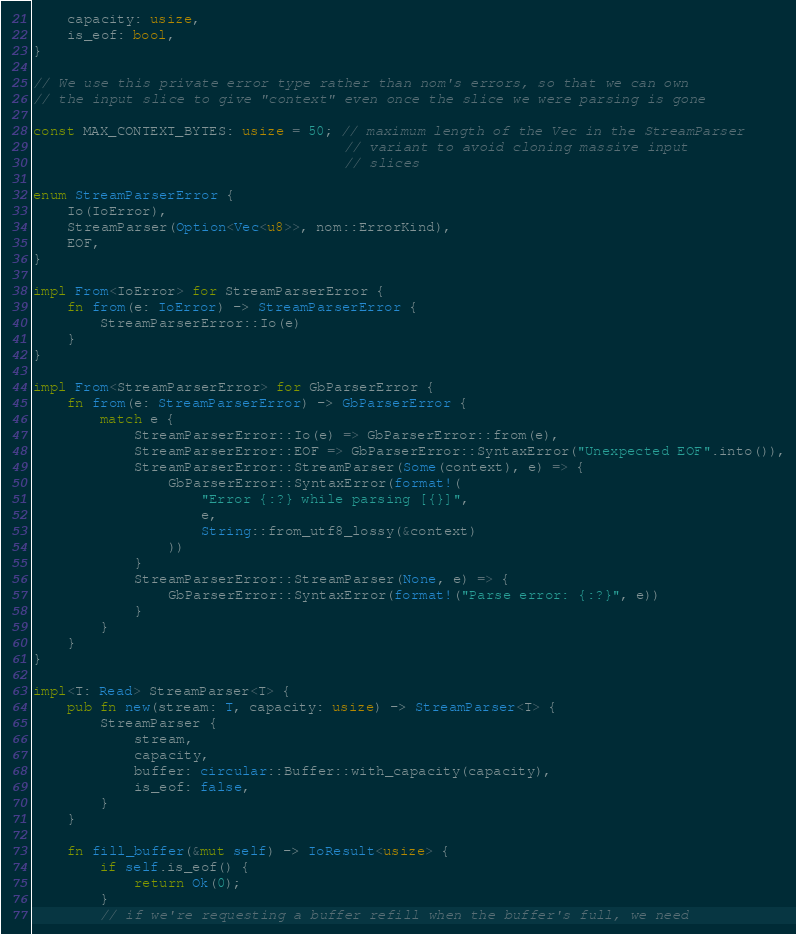<code> <loc_0><loc_0><loc_500><loc_500><_Rust_>    capacity: usize,
    is_eof: bool,
}

// We use this private error type rather than nom's errors, so that we can own
// the input slice to give "context" even once the slice we were parsing is gone

const MAX_CONTEXT_BYTES: usize = 50; // maximum length of the Vec in the StreamParser
                                     // variant to avoid cloning massive input
                                     // slices

enum StreamParserError {
    Io(IoError),
    StreamParser(Option<Vec<u8>>, nom::ErrorKind),
    EOF,
}

impl From<IoError> for StreamParserError {
    fn from(e: IoError) -> StreamParserError {
        StreamParserError::Io(e)
    }
}

impl From<StreamParserError> for GbParserError {
    fn from(e: StreamParserError) -> GbParserError {
        match e {
            StreamParserError::Io(e) => GbParserError::from(e),
            StreamParserError::EOF => GbParserError::SyntaxError("Unexpected EOF".into()),
            StreamParserError::StreamParser(Some(context), e) => {
                GbParserError::SyntaxError(format!(
                    "Error {:?} while parsing [{}]",
                    e,
                    String::from_utf8_lossy(&context)
                ))
            }
            StreamParserError::StreamParser(None, e) => {
                GbParserError::SyntaxError(format!("Parse error: {:?}", e))
            }
        }
    }
}

impl<T: Read> StreamParser<T> {
    pub fn new(stream: T, capacity: usize) -> StreamParser<T> {
        StreamParser {
            stream,
            capacity,
            buffer: circular::Buffer::with_capacity(capacity),
            is_eof: false,
        }
    }

    fn fill_buffer(&mut self) -> IoResult<usize> {
        if self.is_eof() {
            return Ok(0);
        }
        // if we're requesting a buffer refill when the buffer's full, we need</code> 